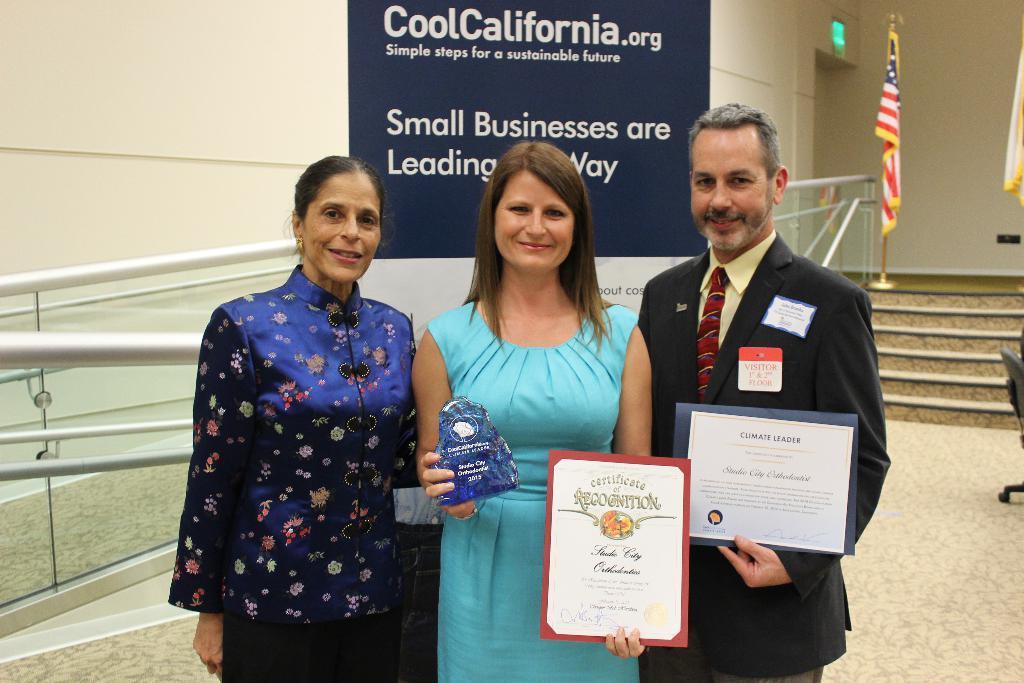Can you describe this image briefly? In this image there are three persons, one person holding a shield, behind them there is the wall, flag, steps, banner attached to the wall on which there is a text. 